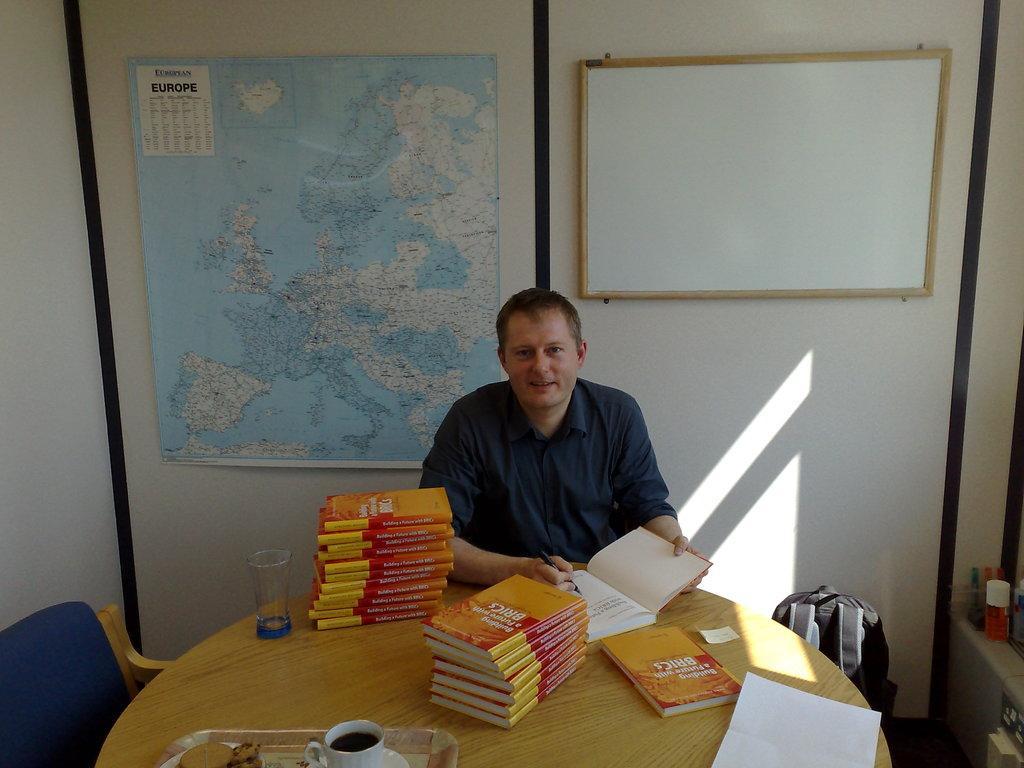Can you describe this image briefly? In this picture we can see man sitting on chair and smiling and writing with pen on book placed on table along with cup drink in it, saucer, biscuits on tray, glass, papers and beside to this we have chair wall with map and board, bag. 